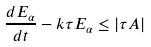<formula> <loc_0><loc_0><loc_500><loc_500>\frac { d E _ { \alpha } } { d t } - k \tau E _ { \alpha } \leq | \tau A |</formula> 